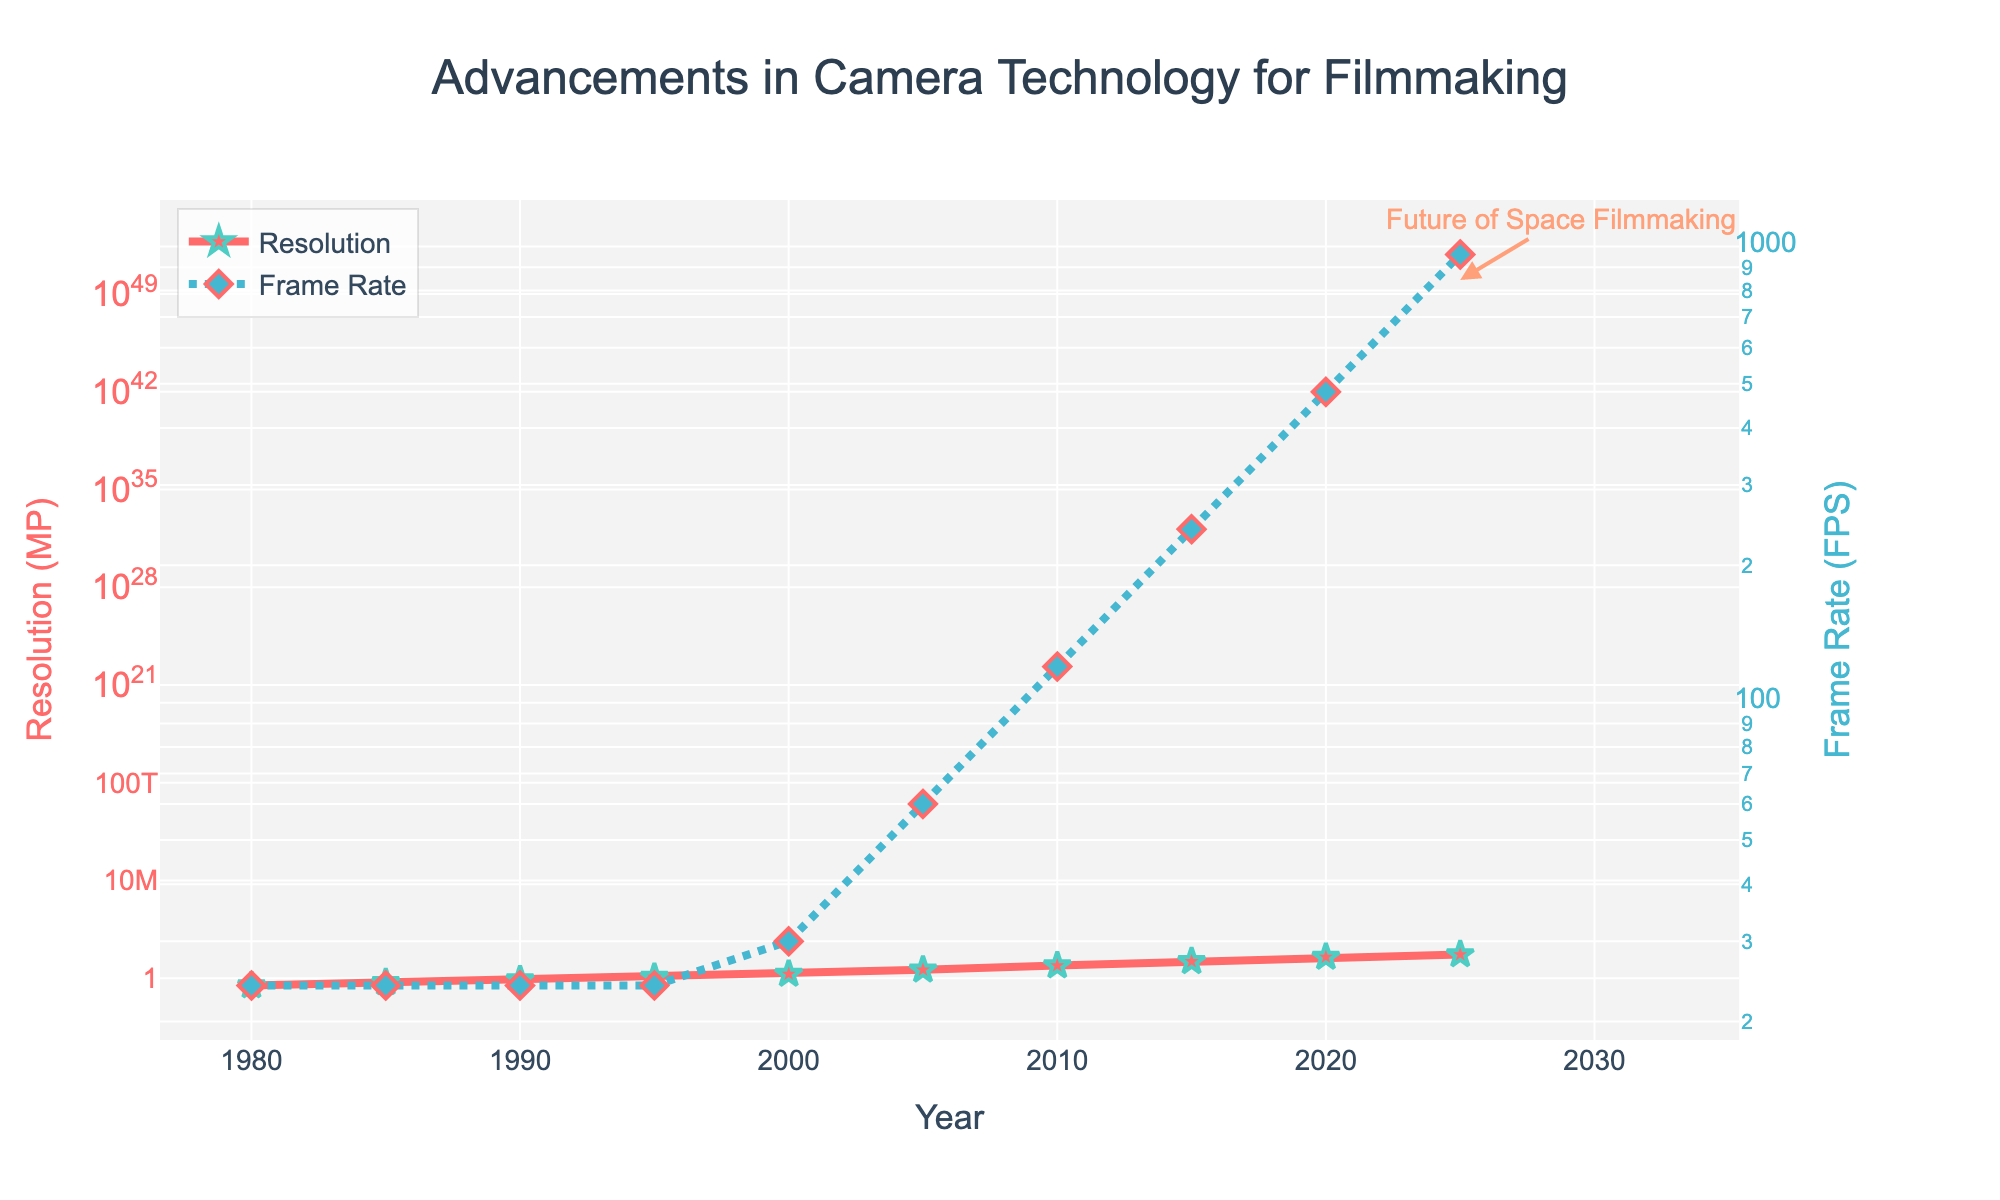What year did the resolution surpass 10 MP? From the figure, the resolution surpasses 10 MP between 2010 and 2015. The data point in 2015 shows a resolution of 16 MP, which is greater than 10 MP.
Answer: 2015 Between which years did the frame rate increase the most rapidly? By observing the steepness of the lines in the figure, the most rapid increase in frame rate occurred between 2020 and 2025, where it jumped from 480 FPS to 960 FPS. This is visually indicated by the steep upward trend.
Answer: 2020 to 2025 What is the approximate ratio of the frame rate (FPS) to the resolution (MP) in the year 2000? The frame rate in 2000 is 30 FPS, and the resolution is 2 MP. The ratio is calculated as 30 / 2 = 15.
Answer: 15 How many years did it take for the resolution to increase from 8 MP to 50 MP? The resolution is 8 MP in 2010 and reaches 50 MP in 2025. To find the number of years, subtract 2010 from 2025, which gives 2025 - 2010 = 15 years.
Answer: 15 years When did frame rate first exceed 100 FPS? The frame rate exceeds 100 FPS between 2005 and 2010. The specific data point in 2010 shows a frame rate of 120 FPS, which is the first time it exceeds 100 FPS.
Answer: 2010 By how many times did the frame rate increase from 1980 to 2025? The frame rate in 1980 is 24 FPS, and it reaches 960 FPS in 2025. The increase is calculated by dividing 960 by 24, which results in 960 / 24 = 40 times.
Answer: 40 times Which advanced more rapidly over time: resolution or frame rate? By comparing the slopes of the lines in the figure, the frame rate shows a more rapid increase, especially noticeable after 2005 with an exponential growth pattern, whereas the resolution increases steadily but at a relatively slower rate.
Answer: Frame rate What is the difference in resolution between the years 2000 and 2020? The resolution in 2000 is 2 MP, and in 2020 it is 33 MP. The difference is calculated by subtracting 2 from 33, which results in 33 - 2 = 31 MP.
Answer: 31 MP How does the resolution trend visually differ from the frame rate trend? The resolution trend shows a relatively steady, continuous increase over the years, represented by a smooth line. In contrast, the frame rate trend shows a more exponential growth, particularly after 2005, visualized by a sharply increasing dotted line.
Answer: Resolution trend is smoother, frame rate trend is exponential At what point does the text "Future of Space Filmmaking" appear, and how does it relate to the trends? The annotation "Future of Space Filmmaking" appears around the year 2025 and a resolution of 50 MP. This indicates a significant point where both the resolution and frame rate are at their highest values in the trend, highlighting the potential advancements in camera technology for future filmmaking in space.
Answer: 2025, 50 MP 